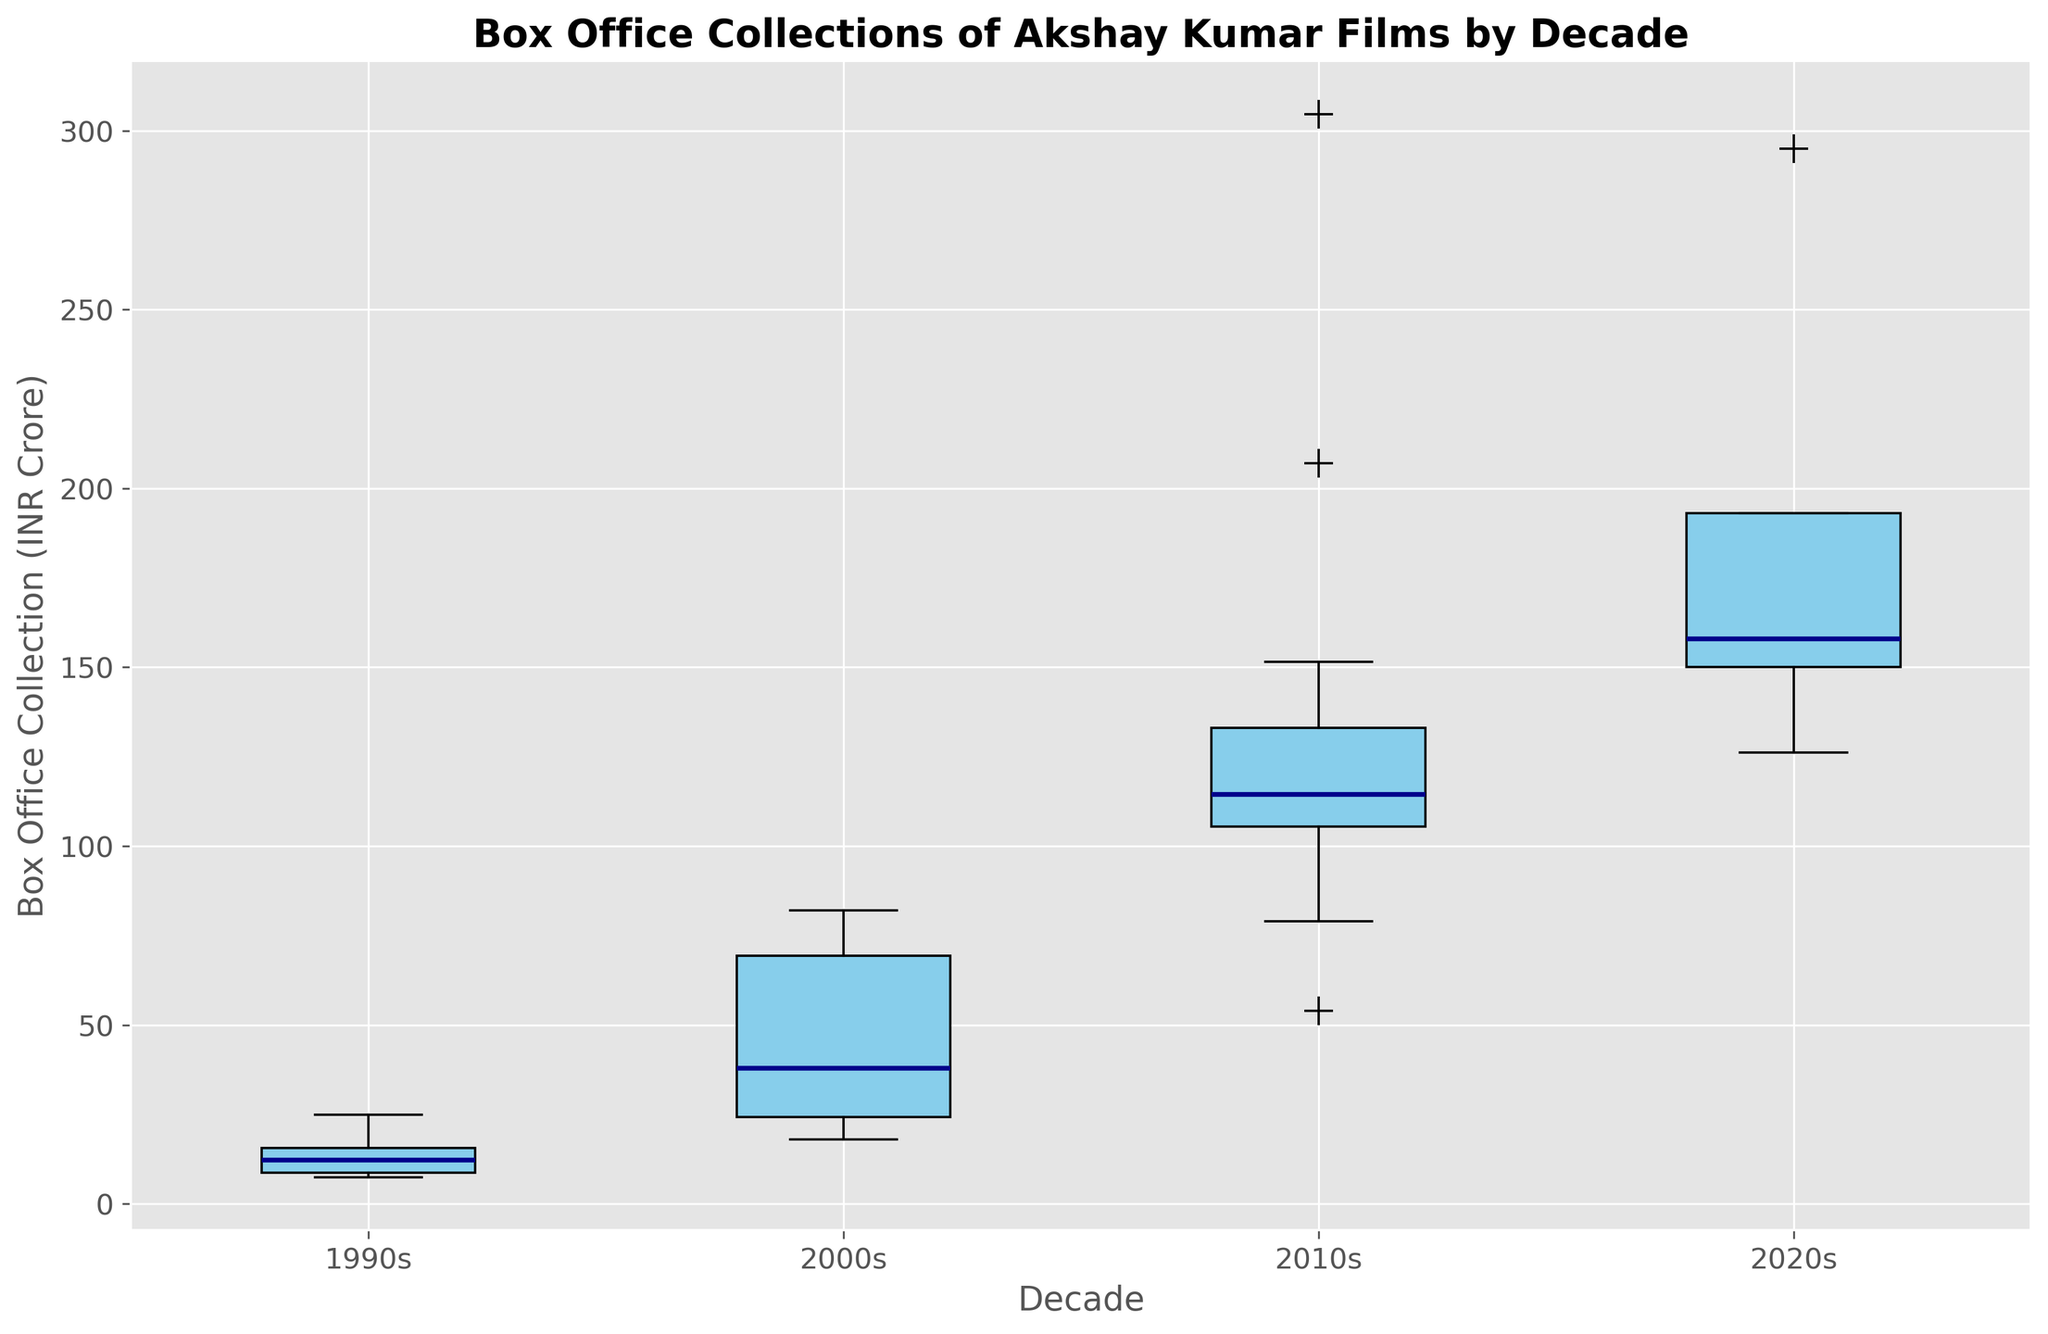What decade had the highest median box office collection? To find the decade with the highest median box office collection, look for the median lines (dark blue) in the box plot. Compare the heights of these median lines across decades. The decade with the highest median line represents the highest median box office collection.
Answer: 2020s Which decade shows the largest range in box office collections? To determine the decade with the largest range, look at the whiskers (the lines that extend from the top and bottom of each box) on the box plot. The range is the difference between the highest and lowest points (the ends of the whiskers). Identify the decade whose whiskers span the greatest vertical distance.
Answer: 2020s How does the interquartile range (IQR) of the 2000s compare to the 1990s? To compare the IQRs, observe the heights of the boxes (the distance between the bottom and top edges of the boxes) for the 2000s and 1990s. The IQR is the difference between the third quartile (the top of the box) and the first quartile (the bottom of the box). Compare these heights to see which is larger.
Answer: The IQR of the 2000s is larger than that of the 1990s Are there any outliers in the 1990s? Outliers in a box plot are typically indicated by individual points that fall outside the whiskers. Look at the 1990s box plot to see if there are any such points.
Answer: No Which decade has the smallest lower whisker length? To find the decade with the smallest lower whisker length, observe the bottom whiskers of each box plot and identify the one that is the shortest (closest to the bottom of the box).
Answer: 1990s What is the median box office collection for the 2010s? To find the median box office collection for the 2010s, look at the position of the median line (dark blue) within the box for the 2010s. The median value is indicated by this line.
Answer: Around INR 113 Crore Compare the upper quartile of the 2020s with the upper quartile of the 2010s. Which one is higher? The upper quartile is the top edge of the box. Compare the positions of the top edges of the boxes for the 2020s and 2010s. The higher top edge indicates the higher upper quartile.
Answer: 2020s Which decade has the most varied box office collections, based on the height of the box? The height of the box represents the IQR, which measures the variability of the data within a decade. Identify the decade with the tallest box to find the one with the most varied box office collections.
Answer: 2020s Do the box office collections in the 2010s have more outliers than in the 2000s? Outliers are shown as individual points outside the whiskers of the box plots. Count the number of outliers for both the 2010s and 2000s by looking for these points.
Answer: Yes Between which decades is the difference in median box office collections the greatest? To find the greatest difference in median box office collections, compare the heights of the median lines (dark blue) across all pairs of decades. Identify the two decades with the most significant height difference.
Answer: 1990s and 2020s 